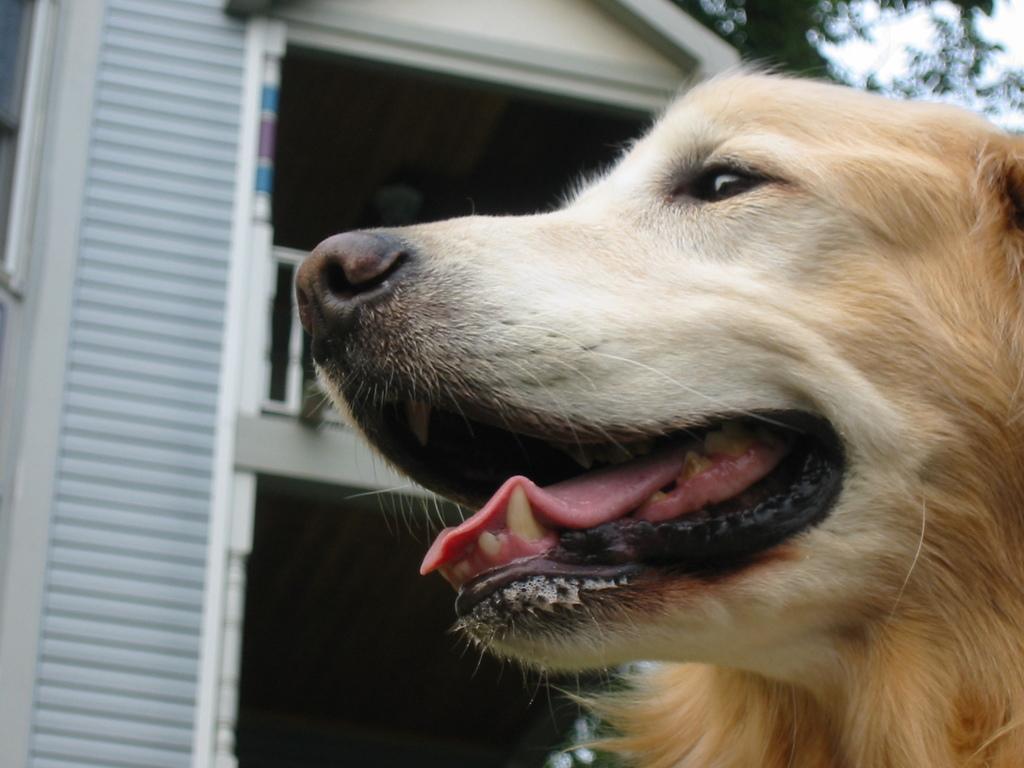How would you summarize this image in a sentence or two? There is a dog which is brown in color in the right corner and there is a building beside it. 